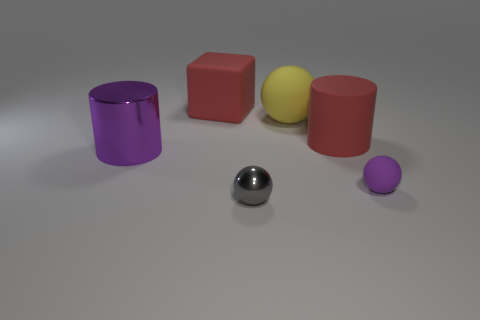Add 1 small purple rubber spheres. How many objects exist? 7 Subtract all cylinders. How many objects are left? 4 Subtract 0 brown balls. How many objects are left? 6 Subtract all small metallic balls. Subtract all big purple shiny cylinders. How many objects are left? 4 Add 5 big yellow spheres. How many big yellow spheres are left? 6 Add 2 red blocks. How many red blocks exist? 3 